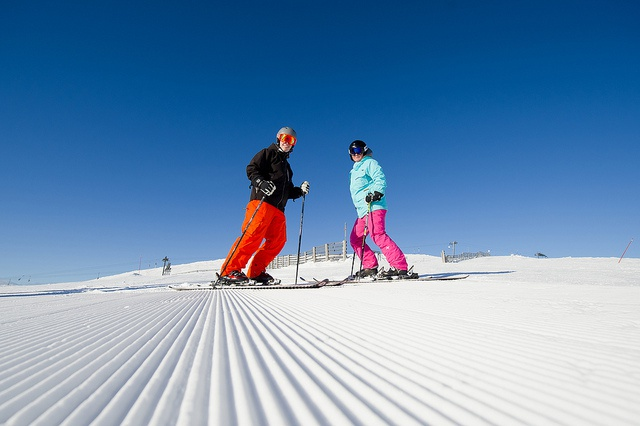Describe the objects in this image and their specific colors. I can see people in darkblue, black, red, and brown tones, people in darkblue, violet, lightblue, and black tones, skis in darkblue, black, darkgray, gray, and lightgray tones, and skis in darkblue, darkgray, gray, and lightgray tones in this image. 